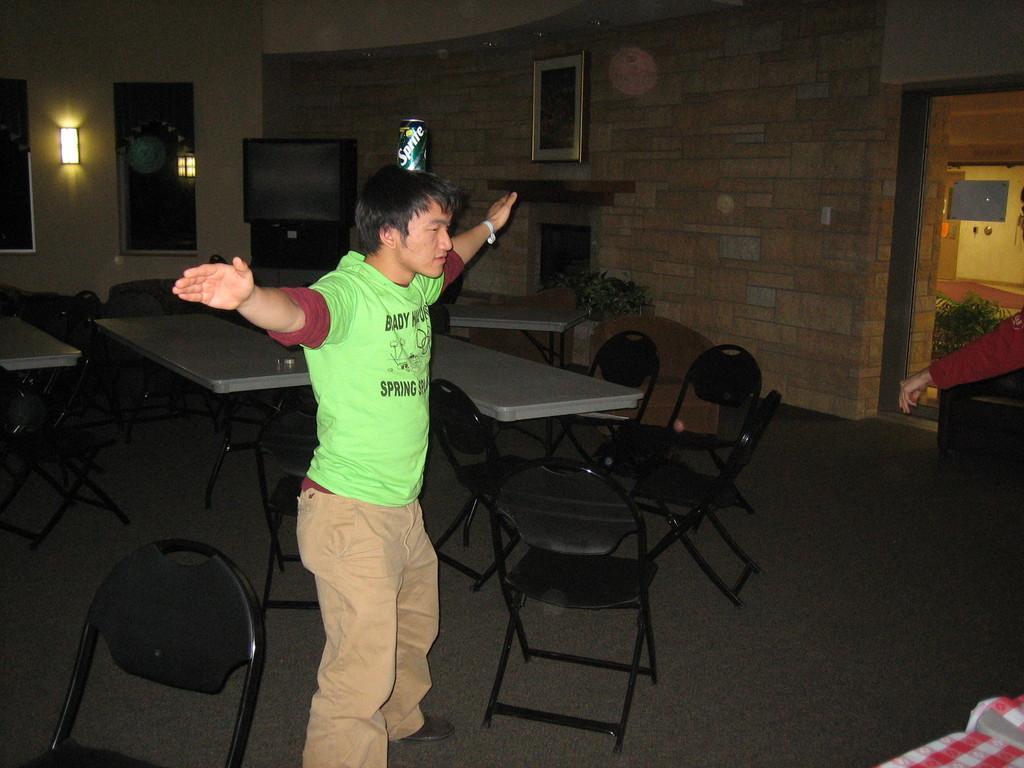How would you summarize this image in a sentence or two? This is the picture inside of the room. There is a person standing in the front. At the back there are tables and chairs and there is a television at the back and at the left there is a window and light. At the top there is a photo frame on the wall, at the bottom there is a mat. 